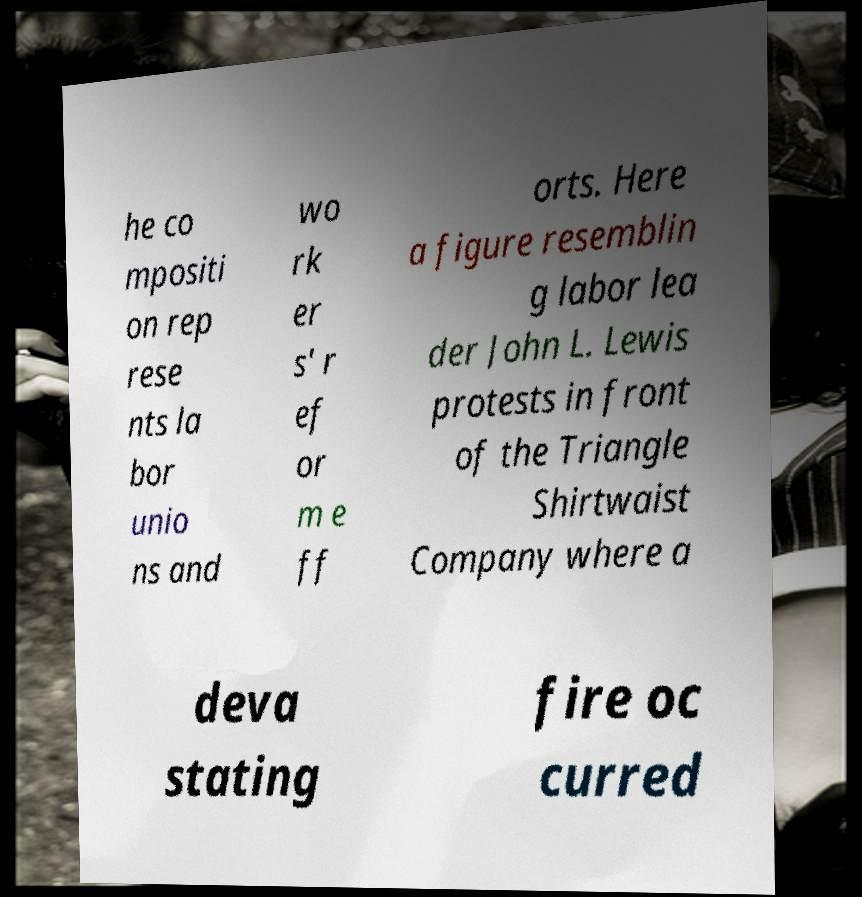Please read and relay the text visible in this image. What does it say? he co mpositi on rep rese nts la bor unio ns and wo rk er s' r ef or m e ff orts. Here a figure resemblin g labor lea der John L. Lewis protests in front of the Triangle Shirtwaist Company where a deva stating fire oc curred 